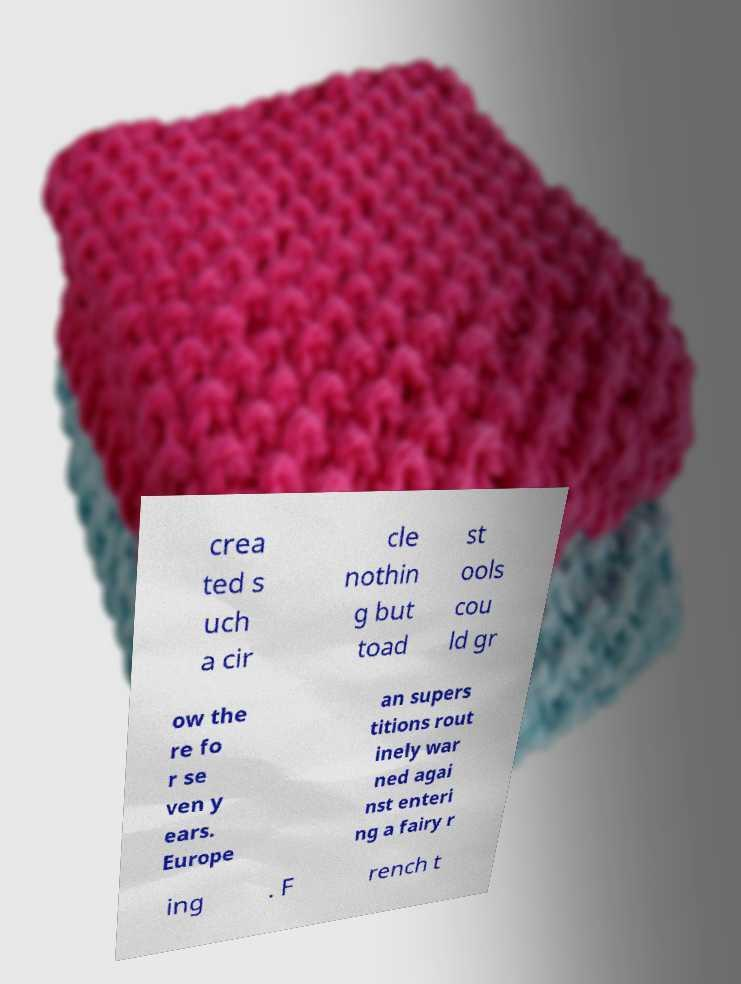What messages or text are displayed in this image? I need them in a readable, typed format. crea ted s uch a cir cle nothin g but toad st ools cou ld gr ow the re fo r se ven y ears. Europe an supers titions rout inely war ned agai nst enteri ng a fairy r ing . F rench t 